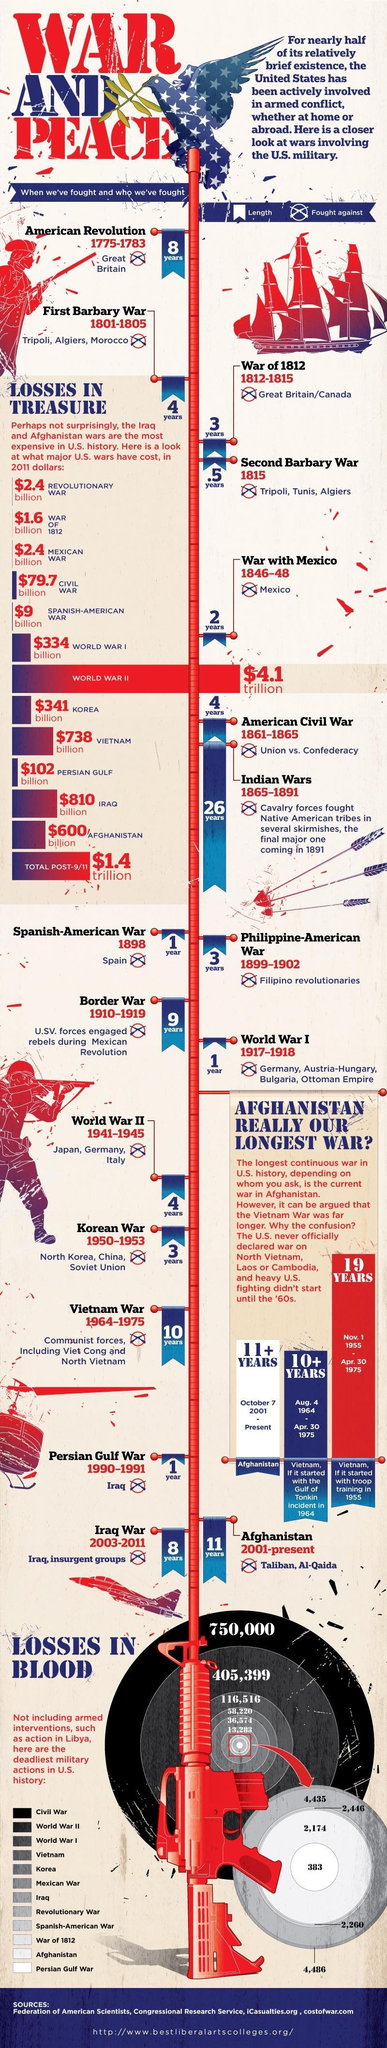When did the Korean War end?
Answer the question with a short phrase. 1953 Which US war had the most casualties? Civil War When did the American Revolutionary War begin? 1775 How long did the War of 1812 last? 3 years Which is the second war in the history of U.S.? War of 1812 Which is the most expensive war in the U.S. history? WORLD WAR II How long did the First Barbary War last? 4 years What is the number of U.S. Military Casualties in World War I? 116,516 What is the number of U.S. Military Casualties in World War II? 405,399 